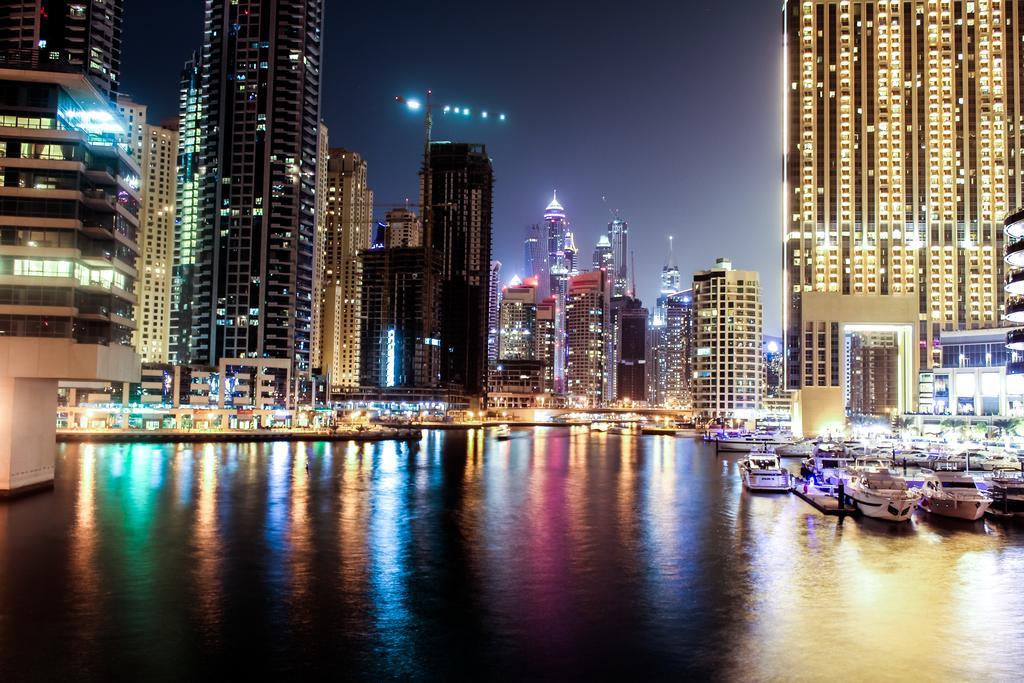How would you summarize this image in a sentence or two? In the foreground of the picture there is a water body. On the right there are boats, buildings and lights. In the center of the picture there are buildings, lights, boards, bridge and other objects. On the left there are buildings. 